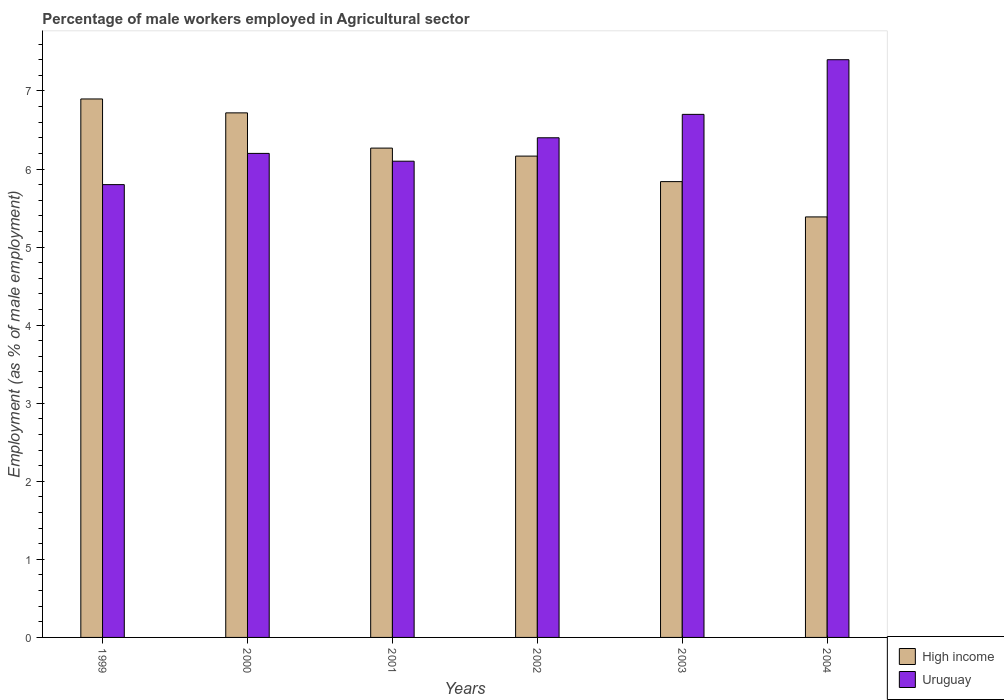How many different coloured bars are there?
Ensure brevity in your answer.  2. Are the number of bars per tick equal to the number of legend labels?
Your response must be concise. Yes. How many bars are there on the 6th tick from the right?
Your answer should be compact. 2. In how many cases, is the number of bars for a given year not equal to the number of legend labels?
Give a very brief answer. 0. What is the percentage of male workers employed in Agricultural sector in Uruguay in 2001?
Provide a short and direct response. 6.1. Across all years, what is the maximum percentage of male workers employed in Agricultural sector in Uruguay?
Give a very brief answer. 7.4. Across all years, what is the minimum percentage of male workers employed in Agricultural sector in Uruguay?
Your answer should be very brief. 5.8. What is the total percentage of male workers employed in Agricultural sector in High income in the graph?
Make the answer very short. 37.27. What is the difference between the percentage of male workers employed in Agricultural sector in High income in 1999 and that in 2003?
Provide a succinct answer. 1.06. What is the difference between the percentage of male workers employed in Agricultural sector in Uruguay in 2001 and the percentage of male workers employed in Agricultural sector in High income in 2002?
Keep it short and to the point. -0.07. What is the average percentage of male workers employed in Agricultural sector in Uruguay per year?
Offer a very short reply. 6.43. In the year 2002, what is the difference between the percentage of male workers employed in Agricultural sector in High income and percentage of male workers employed in Agricultural sector in Uruguay?
Your answer should be very brief. -0.23. In how many years, is the percentage of male workers employed in Agricultural sector in Uruguay greater than 5.8 %?
Ensure brevity in your answer.  6. What is the ratio of the percentage of male workers employed in Agricultural sector in High income in 1999 to that in 2001?
Offer a very short reply. 1.1. Is the difference between the percentage of male workers employed in Agricultural sector in High income in 2002 and 2004 greater than the difference between the percentage of male workers employed in Agricultural sector in Uruguay in 2002 and 2004?
Ensure brevity in your answer.  Yes. What is the difference between the highest and the second highest percentage of male workers employed in Agricultural sector in Uruguay?
Make the answer very short. 0.7. What is the difference between the highest and the lowest percentage of male workers employed in Agricultural sector in Uruguay?
Provide a succinct answer. 1.6. What does the 2nd bar from the left in 2001 represents?
Make the answer very short. Uruguay. What does the 2nd bar from the right in 2001 represents?
Your response must be concise. High income. How many bars are there?
Your answer should be very brief. 12. Are all the bars in the graph horizontal?
Offer a very short reply. No. How many years are there in the graph?
Offer a terse response. 6. Are the values on the major ticks of Y-axis written in scientific E-notation?
Ensure brevity in your answer.  No. Where does the legend appear in the graph?
Your answer should be compact. Bottom right. What is the title of the graph?
Ensure brevity in your answer.  Percentage of male workers employed in Agricultural sector. What is the label or title of the X-axis?
Your response must be concise. Years. What is the label or title of the Y-axis?
Offer a very short reply. Employment (as % of male employment). What is the Employment (as % of male employment) of High income in 1999?
Provide a succinct answer. 6.9. What is the Employment (as % of male employment) in Uruguay in 1999?
Give a very brief answer. 5.8. What is the Employment (as % of male employment) in High income in 2000?
Offer a terse response. 6.72. What is the Employment (as % of male employment) of Uruguay in 2000?
Your response must be concise. 6.2. What is the Employment (as % of male employment) of High income in 2001?
Offer a terse response. 6.27. What is the Employment (as % of male employment) of Uruguay in 2001?
Your answer should be very brief. 6.1. What is the Employment (as % of male employment) in High income in 2002?
Your answer should be compact. 6.17. What is the Employment (as % of male employment) of Uruguay in 2002?
Keep it short and to the point. 6.4. What is the Employment (as % of male employment) in High income in 2003?
Your answer should be compact. 5.84. What is the Employment (as % of male employment) of Uruguay in 2003?
Your answer should be very brief. 6.7. What is the Employment (as % of male employment) of High income in 2004?
Provide a short and direct response. 5.39. What is the Employment (as % of male employment) in Uruguay in 2004?
Your answer should be very brief. 7.4. Across all years, what is the maximum Employment (as % of male employment) in High income?
Your response must be concise. 6.9. Across all years, what is the maximum Employment (as % of male employment) in Uruguay?
Your answer should be very brief. 7.4. Across all years, what is the minimum Employment (as % of male employment) in High income?
Give a very brief answer. 5.39. Across all years, what is the minimum Employment (as % of male employment) of Uruguay?
Offer a very short reply. 5.8. What is the total Employment (as % of male employment) of High income in the graph?
Keep it short and to the point. 37.27. What is the total Employment (as % of male employment) in Uruguay in the graph?
Offer a terse response. 38.6. What is the difference between the Employment (as % of male employment) in High income in 1999 and that in 2000?
Your answer should be very brief. 0.18. What is the difference between the Employment (as % of male employment) in High income in 1999 and that in 2001?
Provide a succinct answer. 0.63. What is the difference between the Employment (as % of male employment) of Uruguay in 1999 and that in 2001?
Provide a short and direct response. -0.3. What is the difference between the Employment (as % of male employment) in High income in 1999 and that in 2002?
Ensure brevity in your answer.  0.73. What is the difference between the Employment (as % of male employment) of Uruguay in 1999 and that in 2002?
Offer a very short reply. -0.6. What is the difference between the Employment (as % of male employment) in High income in 1999 and that in 2003?
Your answer should be compact. 1.06. What is the difference between the Employment (as % of male employment) of High income in 1999 and that in 2004?
Your answer should be compact. 1.51. What is the difference between the Employment (as % of male employment) of Uruguay in 1999 and that in 2004?
Keep it short and to the point. -1.6. What is the difference between the Employment (as % of male employment) of High income in 2000 and that in 2001?
Offer a very short reply. 0.45. What is the difference between the Employment (as % of male employment) of Uruguay in 2000 and that in 2001?
Provide a short and direct response. 0.1. What is the difference between the Employment (as % of male employment) of High income in 2000 and that in 2002?
Provide a short and direct response. 0.55. What is the difference between the Employment (as % of male employment) of Uruguay in 2000 and that in 2002?
Give a very brief answer. -0.2. What is the difference between the Employment (as % of male employment) in High income in 2000 and that in 2003?
Ensure brevity in your answer.  0.88. What is the difference between the Employment (as % of male employment) in High income in 2000 and that in 2004?
Make the answer very short. 1.33. What is the difference between the Employment (as % of male employment) in Uruguay in 2000 and that in 2004?
Offer a very short reply. -1.2. What is the difference between the Employment (as % of male employment) of High income in 2001 and that in 2002?
Provide a succinct answer. 0.1. What is the difference between the Employment (as % of male employment) of Uruguay in 2001 and that in 2002?
Ensure brevity in your answer.  -0.3. What is the difference between the Employment (as % of male employment) in High income in 2001 and that in 2003?
Offer a very short reply. 0.43. What is the difference between the Employment (as % of male employment) of High income in 2001 and that in 2004?
Your response must be concise. 0.88. What is the difference between the Employment (as % of male employment) of Uruguay in 2001 and that in 2004?
Your answer should be very brief. -1.3. What is the difference between the Employment (as % of male employment) in High income in 2002 and that in 2003?
Your answer should be very brief. 0.33. What is the difference between the Employment (as % of male employment) in Uruguay in 2002 and that in 2003?
Offer a terse response. -0.3. What is the difference between the Employment (as % of male employment) in High income in 2002 and that in 2004?
Provide a succinct answer. 0.78. What is the difference between the Employment (as % of male employment) in High income in 2003 and that in 2004?
Give a very brief answer. 0.45. What is the difference between the Employment (as % of male employment) of Uruguay in 2003 and that in 2004?
Provide a short and direct response. -0.7. What is the difference between the Employment (as % of male employment) in High income in 1999 and the Employment (as % of male employment) in Uruguay in 2000?
Your answer should be very brief. 0.7. What is the difference between the Employment (as % of male employment) in High income in 1999 and the Employment (as % of male employment) in Uruguay in 2001?
Give a very brief answer. 0.8. What is the difference between the Employment (as % of male employment) in High income in 1999 and the Employment (as % of male employment) in Uruguay in 2002?
Your answer should be compact. 0.5. What is the difference between the Employment (as % of male employment) in High income in 1999 and the Employment (as % of male employment) in Uruguay in 2003?
Offer a terse response. 0.2. What is the difference between the Employment (as % of male employment) of High income in 1999 and the Employment (as % of male employment) of Uruguay in 2004?
Keep it short and to the point. -0.5. What is the difference between the Employment (as % of male employment) in High income in 2000 and the Employment (as % of male employment) in Uruguay in 2001?
Provide a short and direct response. 0.62. What is the difference between the Employment (as % of male employment) in High income in 2000 and the Employment (as % of male employment) in Uruguay in 2002?
Your response must be concise. 0.32. What is the difference between the Employment (as % of male employment) in High income in 2000 and the Employment (as % of male employment) in Uruguay in 2003?
Offer a very short reply. 0.02. What is the difference between the Employment (as % of male employment) of High income in 2000 and the Employment (as % of male employment) of Uruguay in 2004?
Provide a short and direct response. -0.68. What is the difference between the Employment (as % of male employment) of High income in 2001 and the Employment (as % of male employment) of Uruguay in 2002?
Your answer should be compact. -0.13. What is the difference between the Employment (as % of male employment) in High income in 2001 and the Employment (as % of male employment) in Uruguay in 2003?
Your answer should be very brief. -0.43. What is the difference between the Employment (as % of male employment) of High income in 2001 and the Employment (as % of male employment) of Uruguay in 2004?
Offer a very short reply. -1.13. What is the difference between the Employment (as % of male employment) in High income in 2002 and the Employment (as % of male employment) in Uruguay in 2003?
Provide a succinct answer. -0.53. What is the difference between the Employment (as % of male employment) of High income in 2002 and the Employment (as % of male employment) of Uruguay in 2004?
Make the answer very short. -1.23. What is the difference between the Employment (as % of male employment) in High income in 2003 and the Employment (as % of male employment) in Uruguay in 2004?
Provide a short and direct response. -1.56. What is the average Employment (as % of male employment) of High income per year?
Offer a very short reply. 6.21. What is the average Employment (as % of male employment) in Uruguay per year?
Your answer should be very brief. 6.43. In the year 1999, what is the difference between the Employment (as % of male employment) in High income and Employment (as % of male employment) in Uruguay?
Make the answer very short. 1.1. In the year 2000, what is the difference between the Employment (as % of male employment) of High income and Employment (as % of male employment) of Uruguay?
Give a very brief answer. 0.52. In the year 2001, what is the difference between the Employment (as % of male employment) in High income and Employment (as % of male employment) in Uruguay?
Make the answer very short. 0.17. In the year 2002, what is the difference between the Employment (as % of male employment) of High income and Employment (as % of male employment) of Uruguay?
Offer a terse response. -0.23. In the year 2003, what is the difference between the Employment (as % of male employment) of High income and Employment (as % of male employment) of Uruguay?
Keep it short and to the point. -0.86. In the year 2004, what is the difference between the Employment (as % of male employment) in High income and Employment (as % of male employment) in Uruguay?
Provide a short and direct response. -2.01. What is the ratio of the Employment (as % of male employment) of High income in 1999 to that in 2000?
Give a very brief answer. 1.03. What is the ratio of the Employment (as % of male employment) in Uruguay in 1999 to that in 2000?
Keep it short and to the point. 0.94. What is the ratio of the Employment (as % of male employment) of High income in 1999 to that in 2001?
Offer a very short reply. 1.1. What is the ratio of the Employment (as % of male employment) in Uruguay in 1999 to that in 2001?
Your answer should be very brief. 0.95. What is the ratio of the Employment (as % of male employment) of High income in 1999 to that in 2002?
Provide a short and direct response. 1.12. What is the ratio of the Employment (as % of male employment) of Uruguay in 1999 to that in 2002?
Provide a succinct answer. 0.91. What is the ratio of the Employment (as % of male employment) of High income in 1999 to that in 2003?
Offer a terse response. 1.18. What is the ratio of the Employment (as % of male employment) in Uruguay in 1999 to that in 2003?
Your response must be concise. 0.87. What is the ratio of the Employment (as % of male employment) of High income in 1999 to that in 2004?
Your answer should be compact. 1.28. What is the ratio of the Employment (as % of male employment) of Uruguay in 1999 to that in 2004?
Ensure brevity in your answer.  0.78. What is the ratio of the Employment (as % of male employment) of High income in 2000 to that in 2001?
Offer a terse response. 1.07. What is the ratio of the Employment (as % of male employment) of Uruguay in 2000 to that in 2001?
Make the answer very short. 1.02. What is the ratio of the Employment (as % of male employment) of High income in 2000 to that in 2002?
Offer a terse response. 1.09. What is the ratio of the Employment (as % of male employment) of Uruguay in 2000 to that in 2002?
Give a very brief answer. 0.97. What is the ratio of the Employment (as % of male employment) of High income in 2000 to that in 2003?
Offer a terse response. 1.15. What is the ratio of the Employment (as % of male employment) in Uruguay in 2000 to that in 2003?
Make the answer very short. 0.93. What is the ratio of the Employment (as % of male employment) in High income in 2000 to that in 2004?
Give a very brief answer. 1.25. What is the ratio of the Employment (as % of male employment) in Uruguay in 2000 to that in 2004?
Give a very brief answer. 0.84. What is the ratio of the Employment (as % of male employment) of High income in 2001 to that in 2002?
Your answer should be compact. 1.02. What is the ratio of the Employment (as % of male employment) of Uruguay in 2001 to that in 2002?
Make the answer very short. 0.95. What is the ratio of the Employment (as % of male employment) of High income in 2001 to that in 2003?
Your answer should be compact. 1.07. What is the ratio of the Employment (as % of male employment) in Uruguay in 2001 to that in 2003?
Ensure brevity in your answer.  0.91. What is the ratio of the Employment (as % of male employment) in High income in 2001 to that in 2004?
Offer a very short reply. 1.16. What is the ratio of the Employment (as % of male employment) of Uruguay in 2001 to that in 2004?
Keep it short and to the point. 0.82. What is the ratio of the Employment (as % of male employment) of High income in 2002 to that in 2003?
Provide a short and direct response. 1.06. What is the ratio of the Employment (as % of male employment) of Uruguay in 2002 to that in 2003?
Provide a short and direct response. 0.96. What is the ratio of the Employment (as % of male employment) in High income in 2002 to that in 2004?
Your answer should be very brief. 1.14. What is the ratio of the Employment (as % of male employment) of Uruguay in 2002 to that in 2004?
Your answer should be compact. 0.86. What is the ratio of the Employment (as % of male employment) in High income in 2003 to that in 2004?
Your answer should be compact. 1.08. What is the ratio of the Employment (as % of male employment) in Uruguay in 2003 to that in 2004?
Offer a very short reply. 0.91. What is the difference between the highest and the second highest Employment (as % of male employment) in High income?
Provide a short and direct response. 0.18. What is the difference between the highest and the lowest Employment (as % of male employment) of High income?
Keep it short and to the point. 1.51. What is the difference between the highest and the lowest Employment (as % of male employment) in Uruguay?
Your answer should be compact. 1.6. 